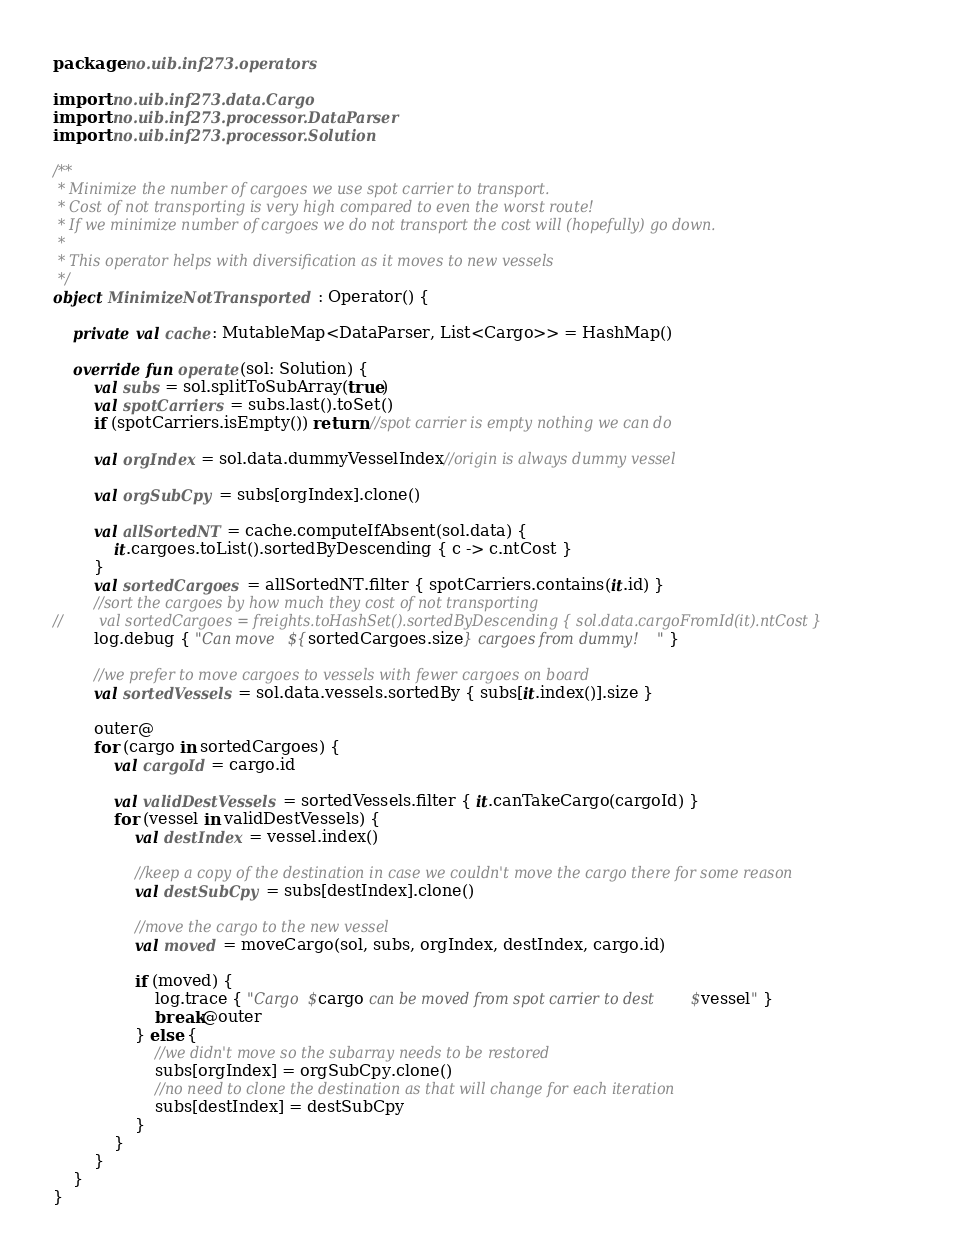<code> <loc_0><loc_0><loc_500><loc_500><_Kotlin_>package no.uib.inf273.operators

import no.uib.inf273.data.Cargo
import no.uib.inf273.processor.DataParser
import no.uib.inf273.processor.Solution

/**
 * Minimize the number of cargoes we use spot carrier to transport.
 * Cost of not transporting is very high compared to even the worst route!
 * If we minimize number of cargoes we do not transport the cost will (hopefully) go down.
 *
 * This operator helps with diversification as it moves to new vessels
 */
object MinimizeNotTransported : Operator() {

    private val cache: MutableMap<DataParser, List<Cargo>> = HashMap()

    override fun operate(sol: Solution) {
        val subs = sol.splitToSubArray(true)
        val spotCarriers = subs.last().toSet()
        if (spotCarriers.isEmpty()) return //spot carrier is empty nothing we can do

        val orgIndex = sol.data.dummyVesselIndex//origin is always dummy vessel

        val orgSubCpy = subs[orgIndex].clone()

        val allSortedNT = cache.computeIfAbsent(sol.data) {
            it.cargoes.toList().sortedByDescending { c -> c.ntCost }
        }
        val sortedCargoes = allSortedNT.filter { spotCarriers.contains(it.id) }
        //sort the cargoes by how much they cost of not transporting
//        val sortedCargoes = freights.toHashSet().sortedByDescending { sol.data.cargoFromId(it).ntCost }
        log.debug { "Can move ${sortedCargoes.size} cargoes from dummy!" }

        //we prefer to move cargoes to vessels with fewer cargoes on board
        val sortedVessels = sol.data.vessels.sortedBy { subs[it.index()].size }

        outer@
        for (cargo in sortedCargoes) {
            val cargoId = cargo.id

            val validDestVessels = sortedVessels.filter { it.canTakeCargo(cargoId) }
            for (vessel in validDestVessels) {
                val destIndex = vessel.index()

                //keep a copy of the destination in case we couldn't move the cargo there for some reason
                val destSubCpy = subs[destIndex].clone()

                //move the cargo to the new vessel
                val moved = moveCargo(sol, subs, orgIndex, destIndex, cargo.id)

                if (moved) {
                    log.trace { "Cargo $cargo can be moved from spot carrier to dest $vessel" }
                    break@outer
                } else {
                    //we didn't move so the subarray needs to be restored
                    subs[orgIndex] = orgSubCpy.clone()
                    //no need to clone the destination as that will change for each iteration
                    subs[destIndex] = destSubCpy
                }
            }
        }
    }
}
</code> 